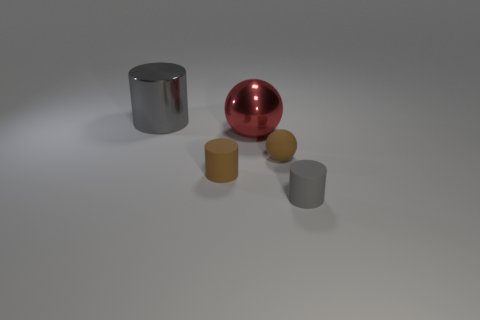There is a rubber cylinder behind the small gray matte cylinder in front of the big object that is behind the red shiny ball; what is its size? The rubber cylinder behind the small gray matte cylinder appears to be medium-sized in relation to the objects present in the image, specifically when considering its size relative to the small gray matte cylinder in front of the larger object and the red shiny ball. 